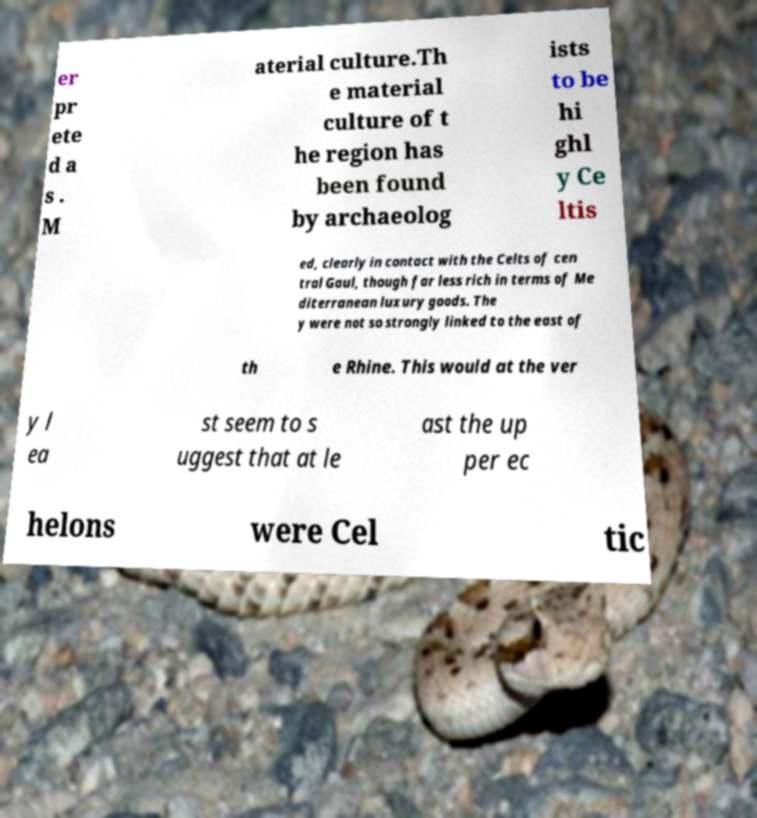Please read and relay the text visible in this image. What does it say? er pr ete d a s . M aterial culture.Th e material culture of t he region has been found by archaeolog ists to be hi ghl y Ce ltis ed, clearly in contact with the Celts of cen tral Gaul, though far less rich in terms of Me diterranean luxury goods. The y were not so strongly linked to the east of th e Rhine. This would at the ver y l ea st seem to s uggest that at le ast the up per ec helons were Cel tic 